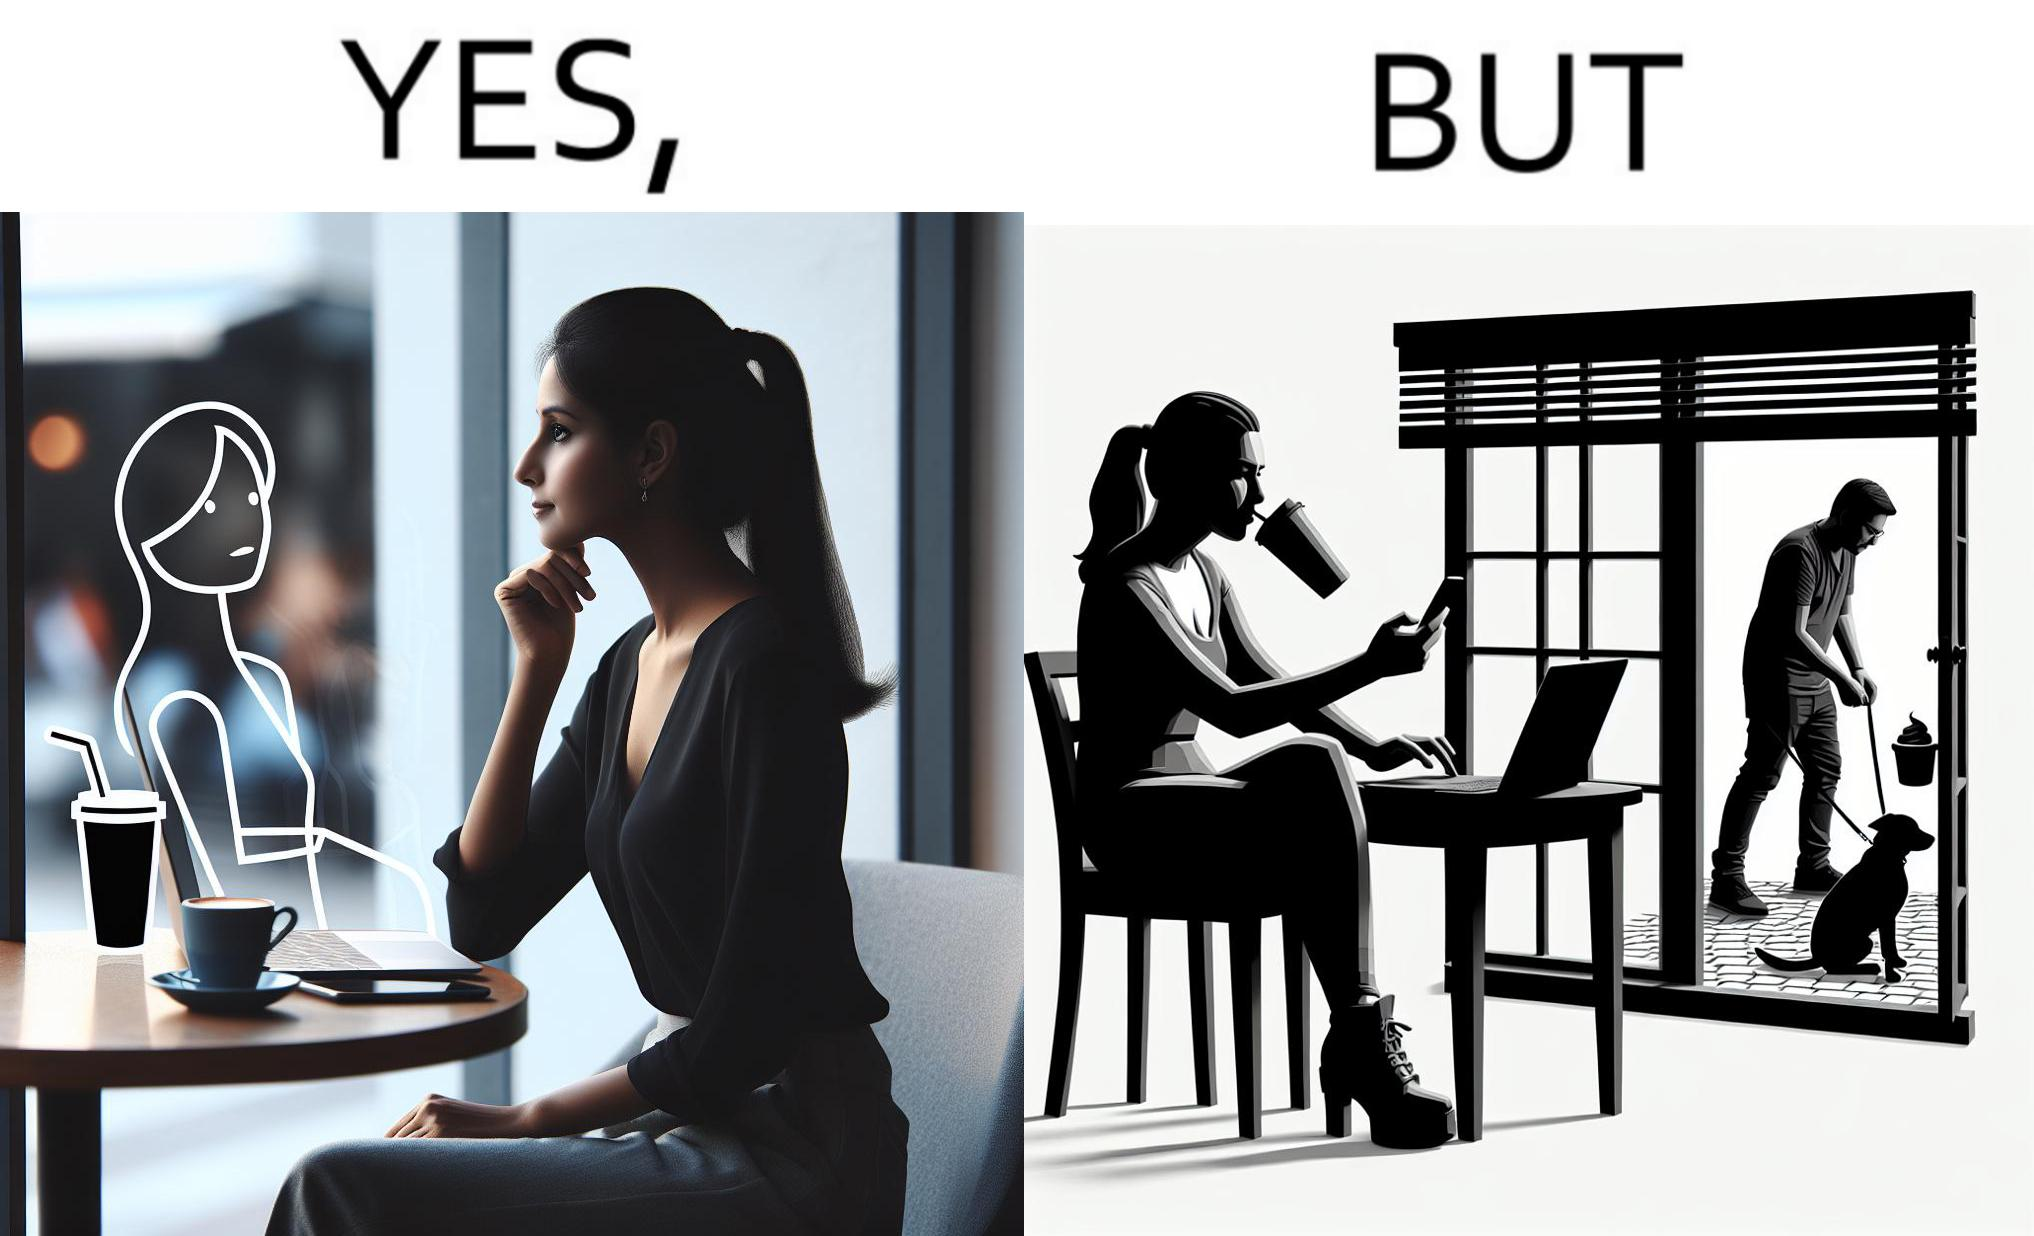What is shown in this image? The image is ironic, because in the first image the woman is seen as enjoying the view but in the second image the same woman is seen as looking at a pooping dog 